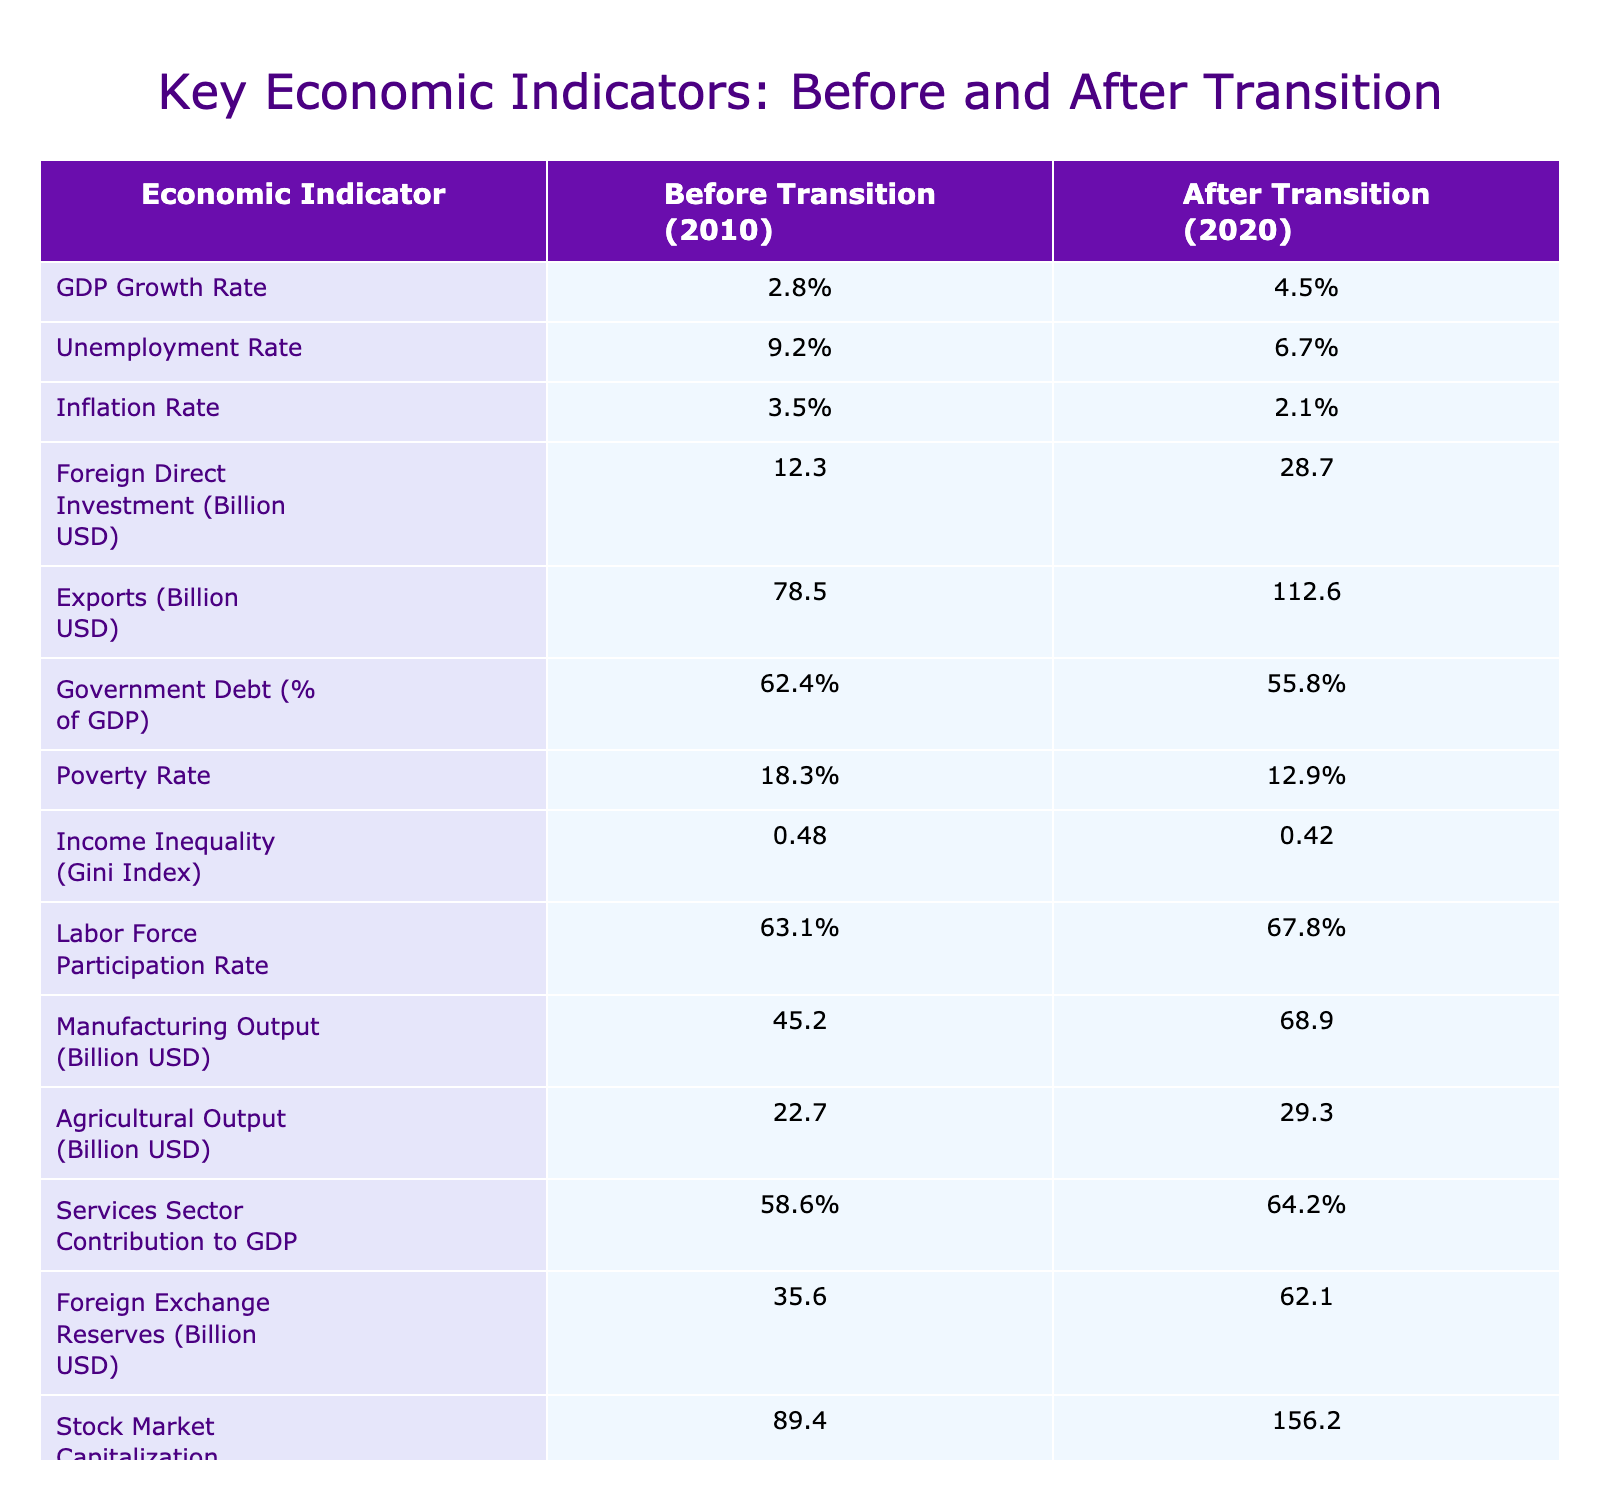What was the GDP growth rate before the transition? The GDP growth rate before the transition is listed in the table under "Before Transition (2010)" which shows a value of 2.8%.
Answer: 2.8% What is the unemployment rate after the transition? The unemployment rate after the transition can be found under "After Transition (2020)" in the table, which indicates a rate of 6.7%.
Answer: 6.7% What was the difference in the poverty rate before and after the transition? The poverty rate before the transition was 18.3% and after the transition it is 12.9%. The difference is calculated as 18.3% - 12.9% = 5.4%.
Answer: 5.4% Did the foreign direct investment increase or decrease after the transition? By comparing the values from the "Before Transition (2010)" which was 12.3 billion USD and "After Transition (2020)" which is 28.7 billion USD, we can see that it increased.
Answer: Yes What is the percentage change in government debt from before to after the transition? The government debt before the transition was 62.4% and after the transition it decreased to 55.8%. The percentage change is calculated as (62.4% - 55.8%) / 62.4% * 100 = 10.59%.
Answer: 10.59% Which indicator showed the largest numerical increase from before to after the transition? By examining the table, we compare the numerical values for all indicators. The foreign exchange reserves increased from 35.6 billion USD to 62.1 billion USD, which is the largest increase of 26.5 billion USD.
Answer: Foreign Exchange Reserves Did the inflation rate increase or decrease after the transition? The inflation rate before the transition was 3.5% and after the transition it is 2.1%. This indicates a decrease in the inflation rate.
Answer: Decrease What was the increase in manufacturing output as measured in billion USD? The manufacturing output before the transition was 45.2 billion USD and after was 68.9 billion USD. The increase is calculated as 68.9 billion USD - 45.2 billion USD = 23.7 billion USD.
Answer: 23.7 billion USD Summarize the change in the services sector contribution to GDP. The services sector contribution to GDP before the transition was 58.6% and after it increased to 64.2%. This shows a rise in the services sector's contribution.
Answer: Increased What is the average of the foreign direct investment and exports after the transition? The values after the transition are 28.7 billion USD for FDI and 112.6 billion USD for exports. The average is calculated by (28.7 + 112.6) / 2 = 70.65 billion USD.
Answer: 70.65 billion USD 